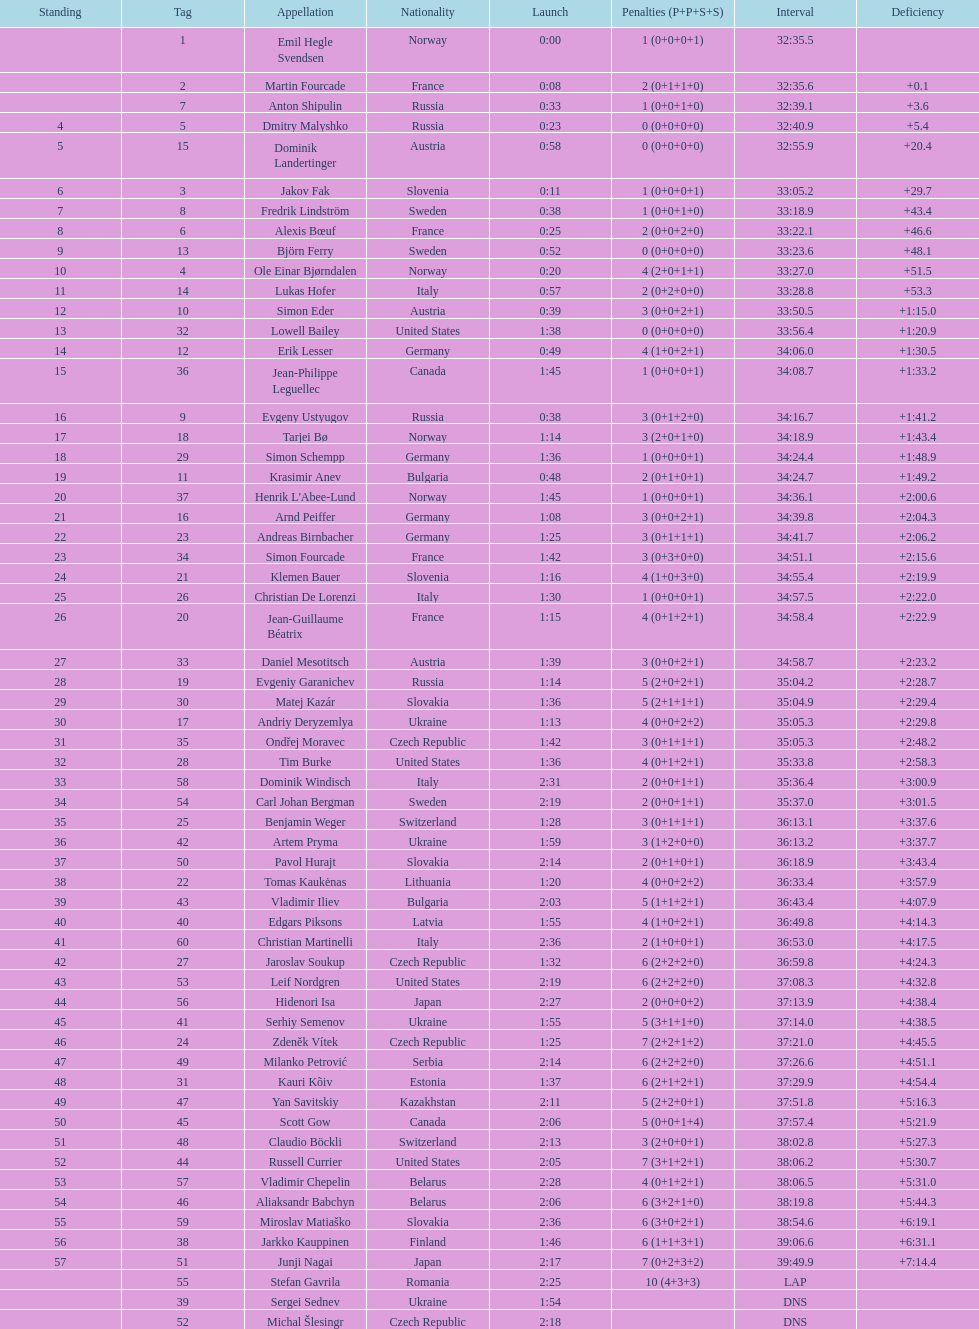How long did it take for erik lesser to finish? 34:06.0. 